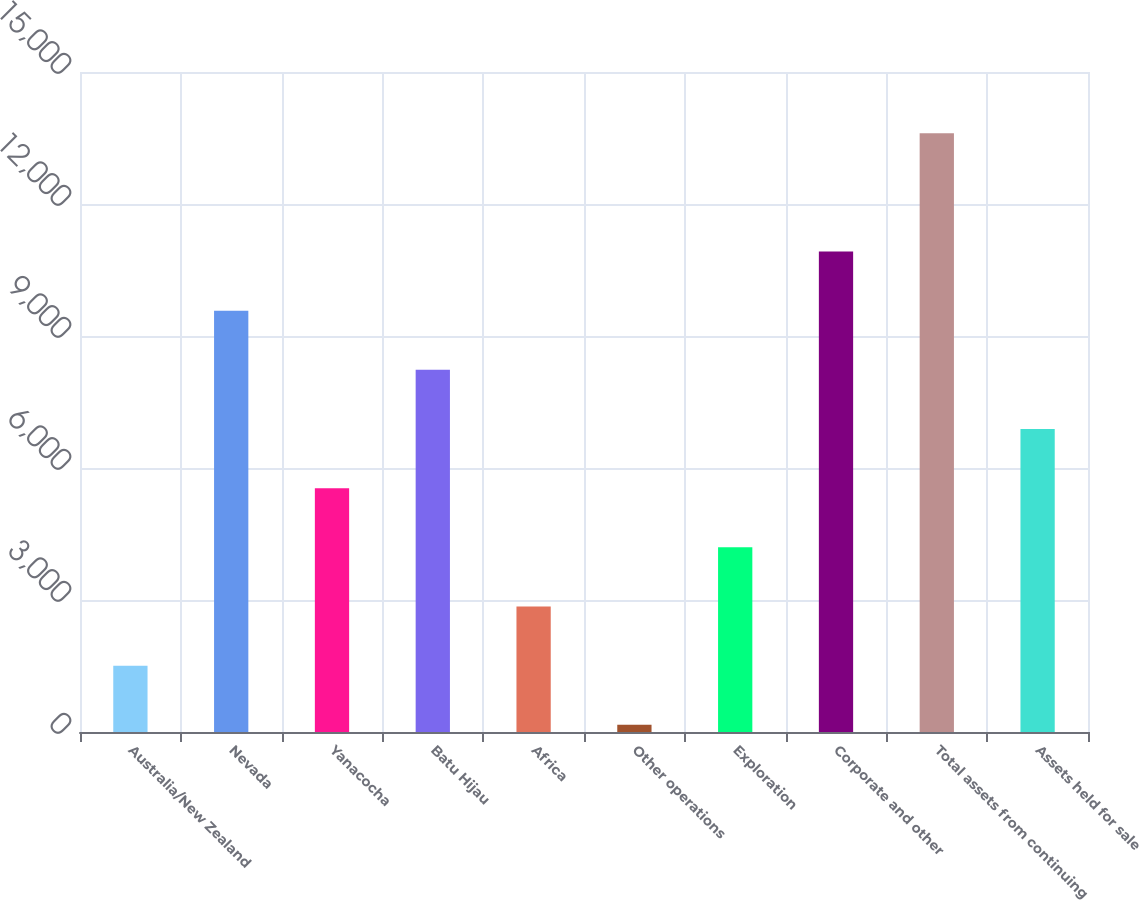<chart> <loc_0><loc_0><loc_500><loc_500><bar_chart><fcel>Australia/New Zealand<fcel>Nevada<fcel>Yanacocha<fcel>Batu Hijau<fcel>Africa<fcel>Other operations<fcel>Exploration<fcel>Corporate and other<fcel>Total assets from continuing<fcel>Assets held for sale<nl><fcel>1507.6<fcel>9575.2<fcel>5541.4<fcel>8230.6<fcel>2852.2<fcel>163<fcel>4196.8<fcel>10919.8<fcel>13609<fcel>6886<nl></chart> 